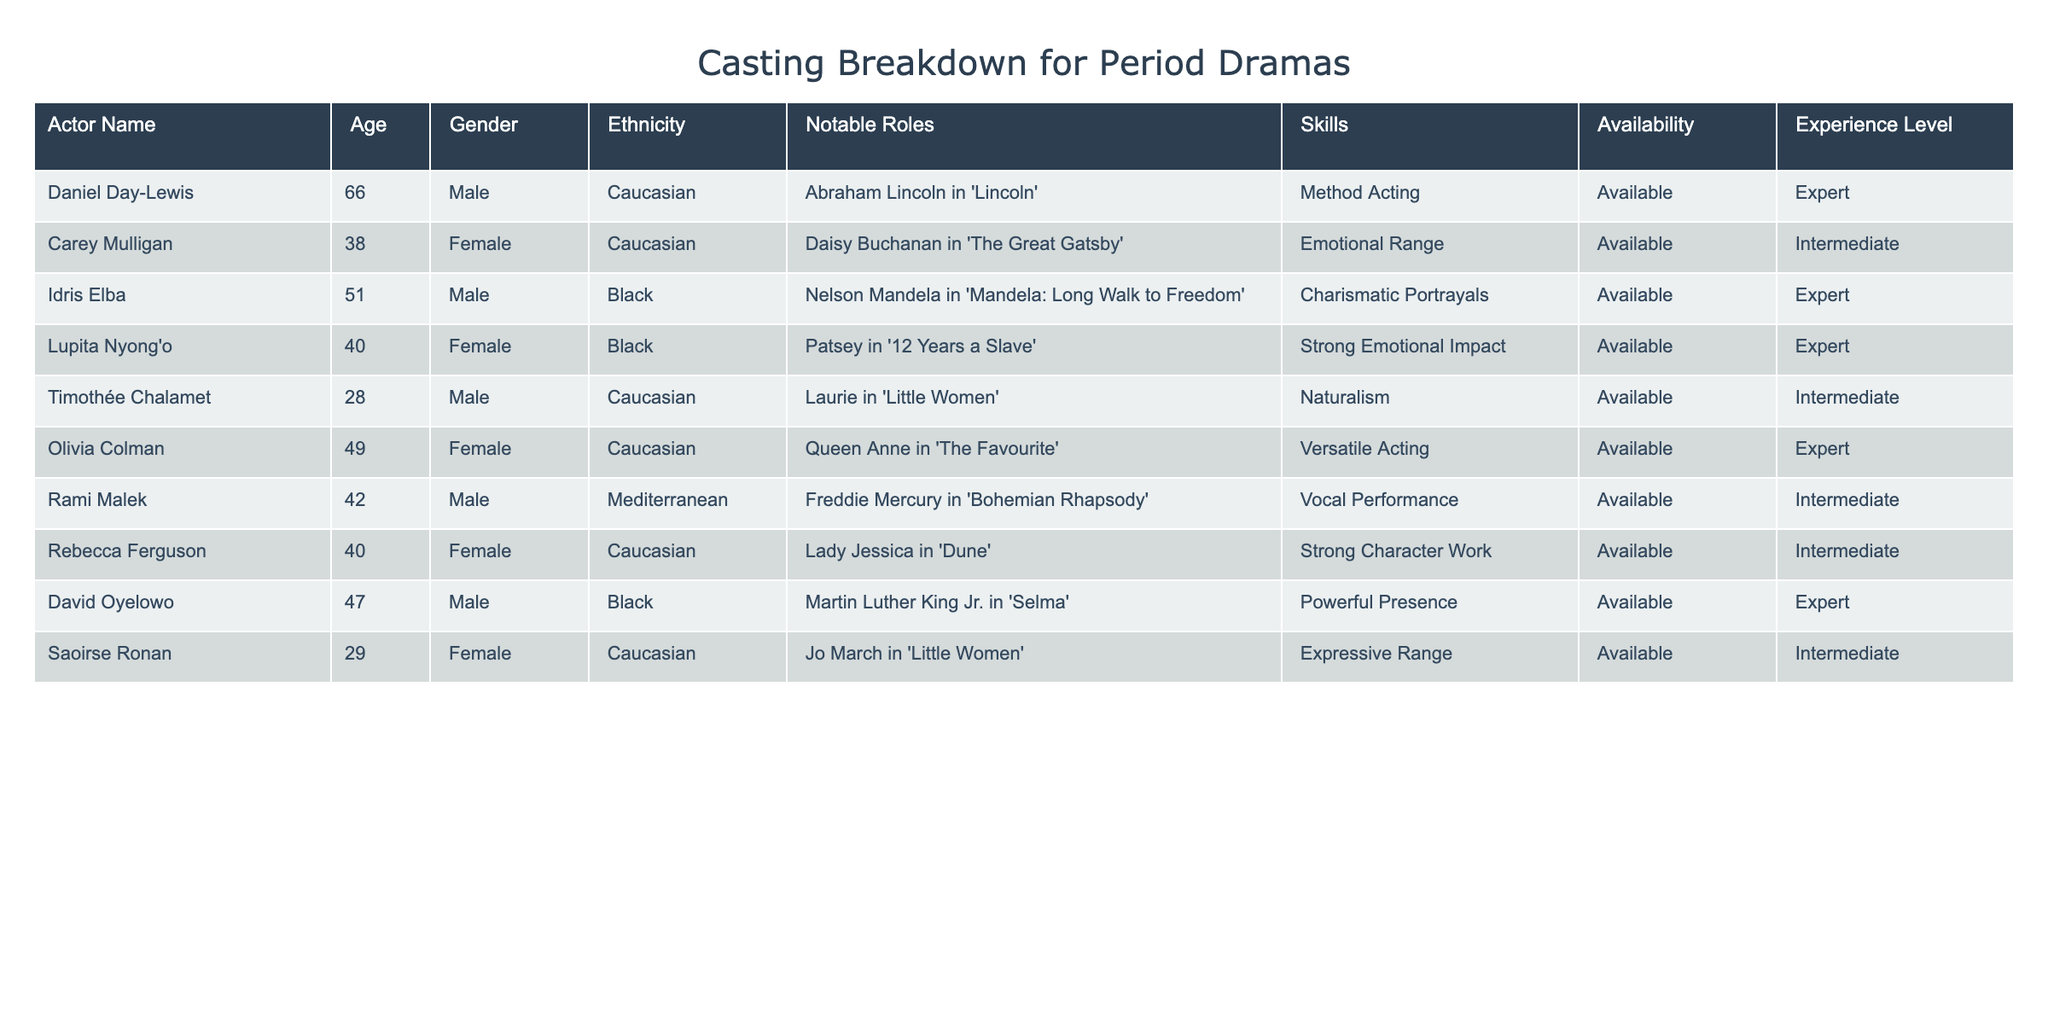What is the age of Daniel Day-Lewis? The table shows that Daniel Day-Lewis is listed with an age of 66.
Answer: 66 How many expert-level actors are available? From the table, we see that there are four actors with an experience level marked as 'Expert': Daniel Day-Lewis, Idris Elba, Lupita Nyong'o, and Olivia Colman.
Answer: 4 Are there any female actors who are available and have an emotional range skill? The table indicates that Carey Mulligan has the skill of emotional range, and she is available. Therefore, the answer is yes.
Answer: Yes What is the notable role of Rami Malek? According to the table, Rami Malek is noted for his role as Freddie Mercury in 'Bohemian Rhapsody'.
Answer: Freddie Mercury in 'Bohemian Rhapsody' Which actor among the group has the highest age? Comparing the ages of all actors, Daniel Day-Lewis is the oldest at 66 years.
Answer: 66 How many male actors have an availability status of 'Available' and an experience level of 'Intermediate'? The table shows there are two male actors who fulfill both criteria: Rami Malek and Timothée Chalamet. Thus, the total is 2.
Answer: 2 Is Lupita Nyong'o younger than Olivia Colman? Lupita Nyong'o is 40 years old, while Olivia Colman is 49 years old. Since 40 is less than 49, the answer is yes.
Answer: Yes What proportion of actors are available with a background in Black ethnicity? The table lists three actors of Black ethnicity who are all available: Idris Elba, Lupita Nyong'o, and David Oyelowo. Since there are ten actors in total, the proportion is 3 out of 10, or 30%.
Answer: 30% Which actor has the skill of versatile acting and what is her age? The table indicates that Olivia Colman has the skill of versatile acting, and she is currently 49 years old.
Answer: 49 